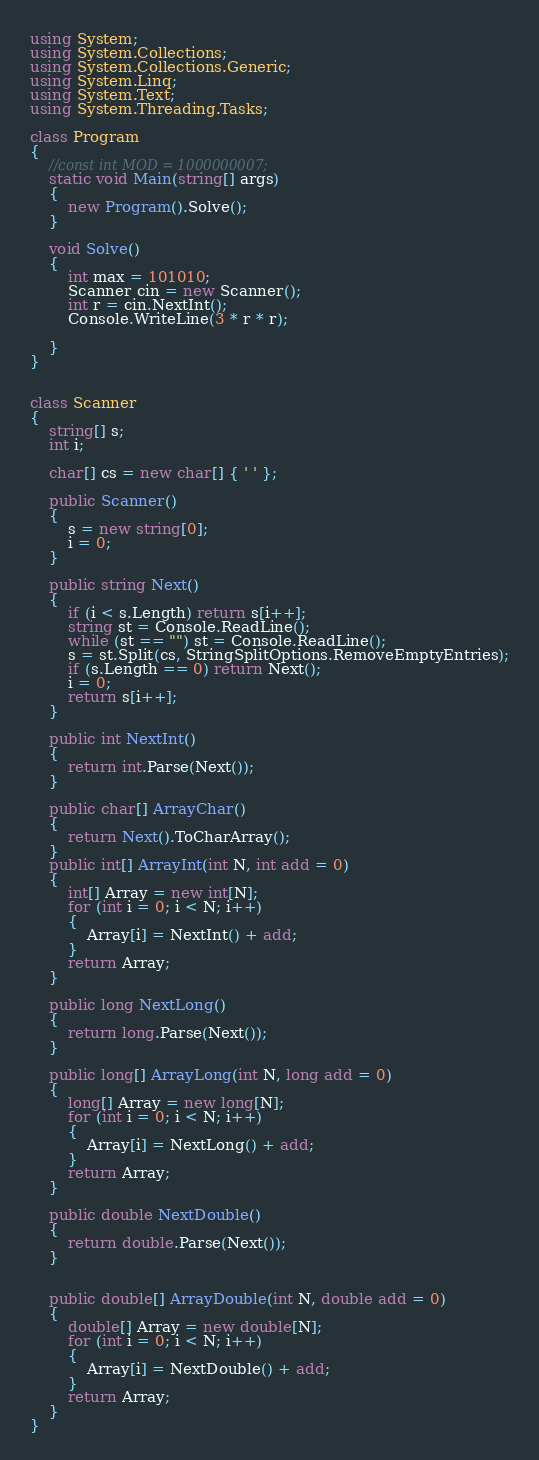Convert code to text. <code><loc_0><loc_0><loc_500><loc_500><_C#_>using System;
using System.Collections;
using System.Collections.Generic;
using System.Linq;
using System.Text;
using System.Threading.Tasks;

class Program
{
    //const int MOD = 1000000007;
    static void Main(string[] args)
    {
        new Program().Solve();
    }

    void Solve()
    {
        int max = 101010;
        Scanner cin = new Scanner();
        int r = cin.NextInt();
        Console.WriteLine(3 * r * r);

    }
}


class Scanner
{
    string[] s;
    int i;

    char[] cs = new char[] { ' ' };

    public Scanner()
    {
        s = new string[0];
        i = 0;
    }

    public string Next()
    {
        if (i < s.Length) return s[i++];
        string st = Console.ReadLine();
        while (st == "") st = Console.ReadLine();
        s = st.Split(cs, StringSplitOptions.RemoveEmptyEntries);
        if (s.Length == 0) return Next();
        i = 0;
        return s[i++];
    }

    public int NextInt()
    {
        return int.Parse(Next());
    }

    public char[] ArrayChar()
    {
        return Next().ToCharArray();
    }
    public int[] ArrayInt(int N, int add = 0)
    {
        int[] Array = new int[N];
        for (int i = 0; i < N; i++)
        {
            Array[i] = NextInt() + add;
        }
        return Array;
    }

    public long NextLong()
    {
        return long.Parse(Next());
    }

    public long[] ArrayLong(int N, long add = 0)
    {
        long[] Array = new long[N];
        for (int i = 0; i < N; i++)
        {
            Array[i] = NextLong() + add;
        }
        return Array;
    }

    public double NextDouble()
    {
        return double.Parse(Next());
    }


    public double[] ArrayDouble(int N, double add = 0)
    {
        double[] Array = new double[N];
        for (int i = 0; i < N; i++)
        {
            Array[i] = NextDouble() + add;
        }
        return Array;
    }
}
</code> 